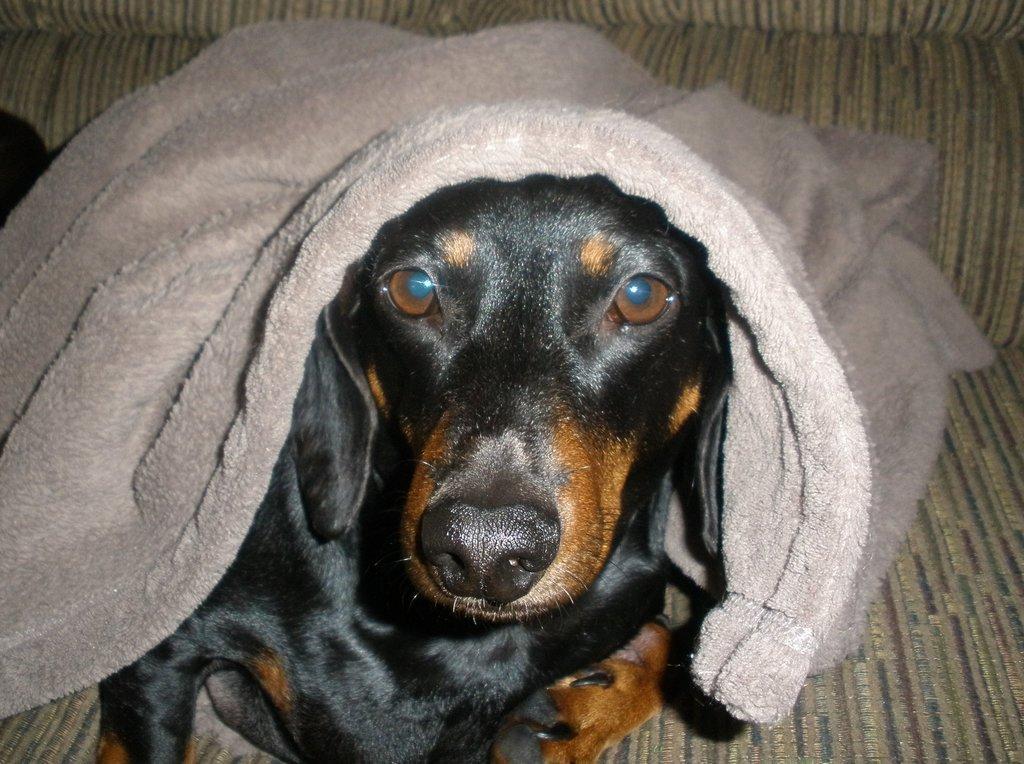Could you give a brief overview of what you see in this image? In this image I can see a dog in black and brown color. I can see a grey cloth on the dog. 